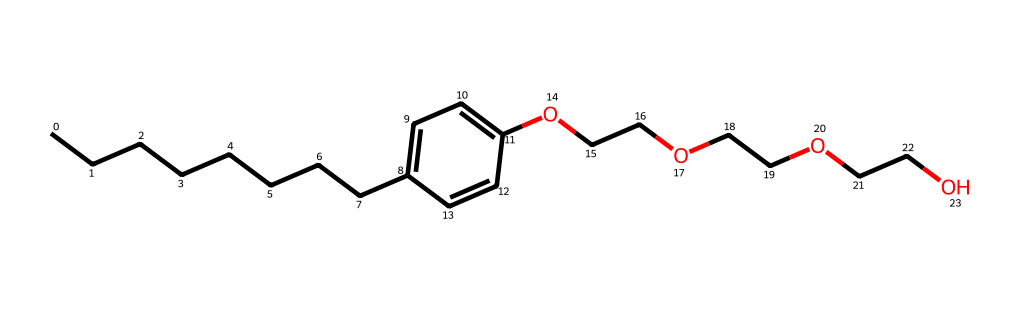What is the main functional group in this compound? The presence of the -OCCO- chain in the structure indicates the presence of ether functional groups, which are characterized by an oxygen atom bonded to two carbon atoms.
Answer: ether How many carbon atoms are in the molecule? By counting the carbon atoms represented in the SMILES notation, there are 15 carbon atoms in total in the entire structure.
Answer: 15 What type of compound is nonylphenol ethoxylate? This compound is categorized as a nonionic surfactant, which is characterized by its ability to reduce surface tension and is often used in detergents.
Answer: nonionic surfactant How many ethoxy groups are present in this molecule? The structure reveals three ethylene glycol units (-OCCO-), each of which corresponds to one ethoxy group; therefore, there are three ethoxy groups in total.
Answer: 3 What property is primarily affected by the length of the hydrophobic chain in this chemical? The length of the hydrophobic chain significantly influences the detergent's surface activity; longer chains typically enhance the solubility of grease and oils, optimizing cleaning performance in various conditions.
Answer: solubility 